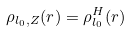Convert formula to latex. <formula><loc_0><loc_0><loc_500><loc_500>\label O \lim _ { Z \rightarrow \infty } \rho _ { l _ { 0 } , Z } ( r ) = \rho ^ { H } _ { l _ { 0 } } ( r )</formula> 